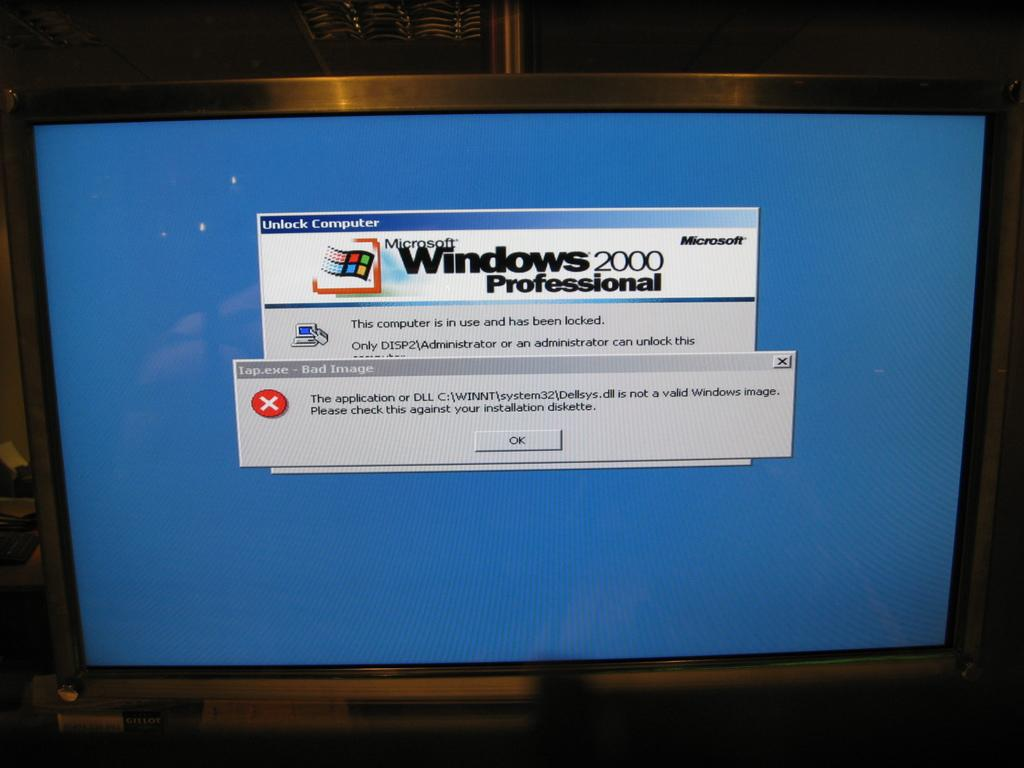Provide a one-sentence caption for the provided image. An error message and Windows 2000 professional appear on the blue screen of a computer screen. 